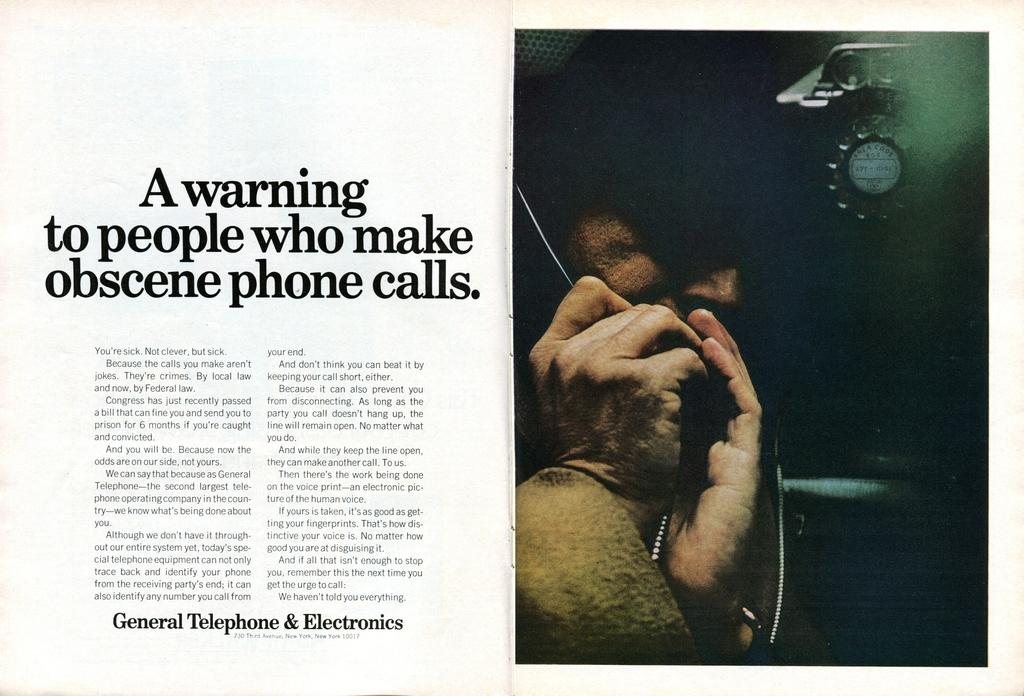What is present on the left side of the image? There is text on the left side of the image. Can you describe the person on the right side of the image? There is a person on the right side of the image, but no specific details about their appearance or actions are provided. What is the main object in the image? The main object in the image is a paper. What flavor of cake is being served at the event in the image? There is no event or cake present in the image; it only features a paper and a person. 